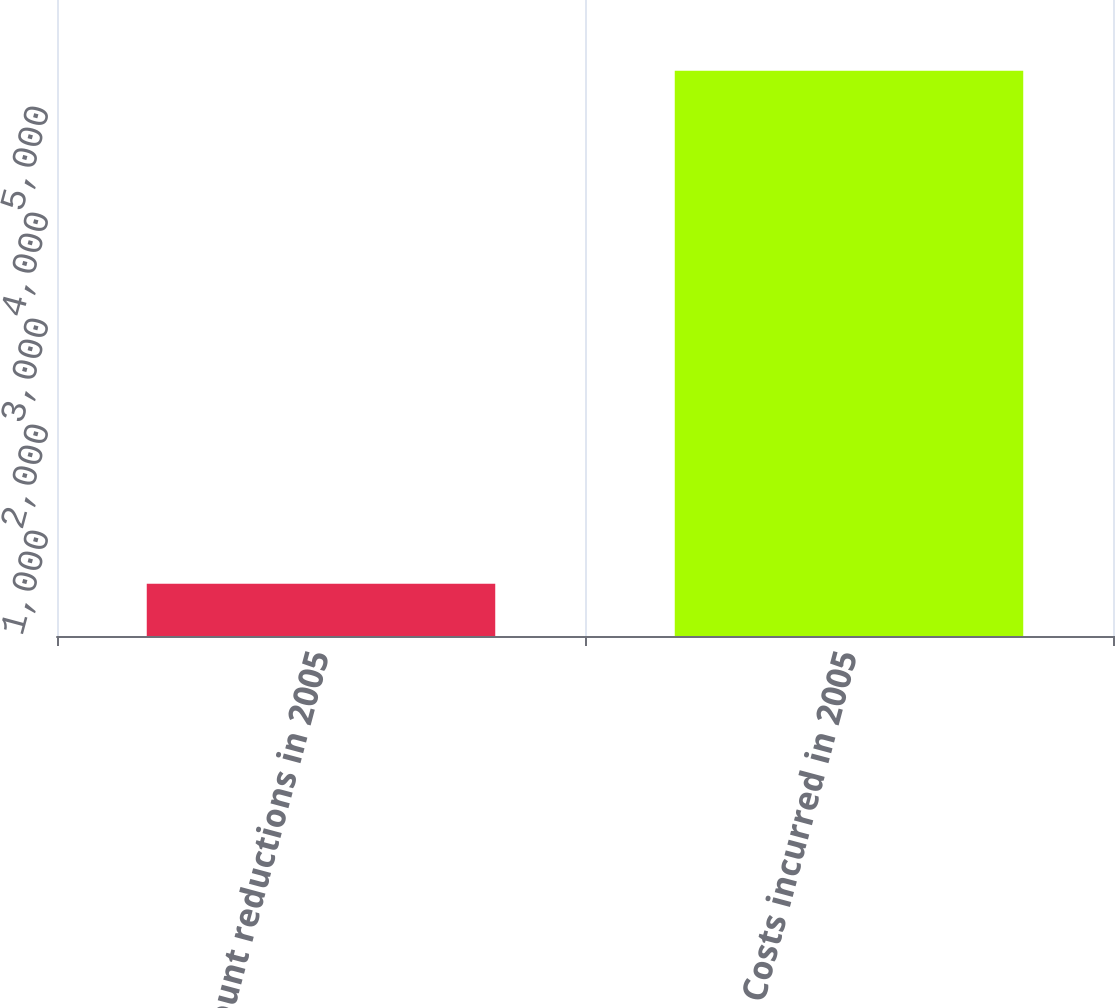<chart> <loc_0><loc_0><loc_500><loc_500><bar_chart><fcel>Headcount reductions in 2005<fcel>Costs incurred in 2005<nl><fcel>494<fcel>5333<nl></chart> 